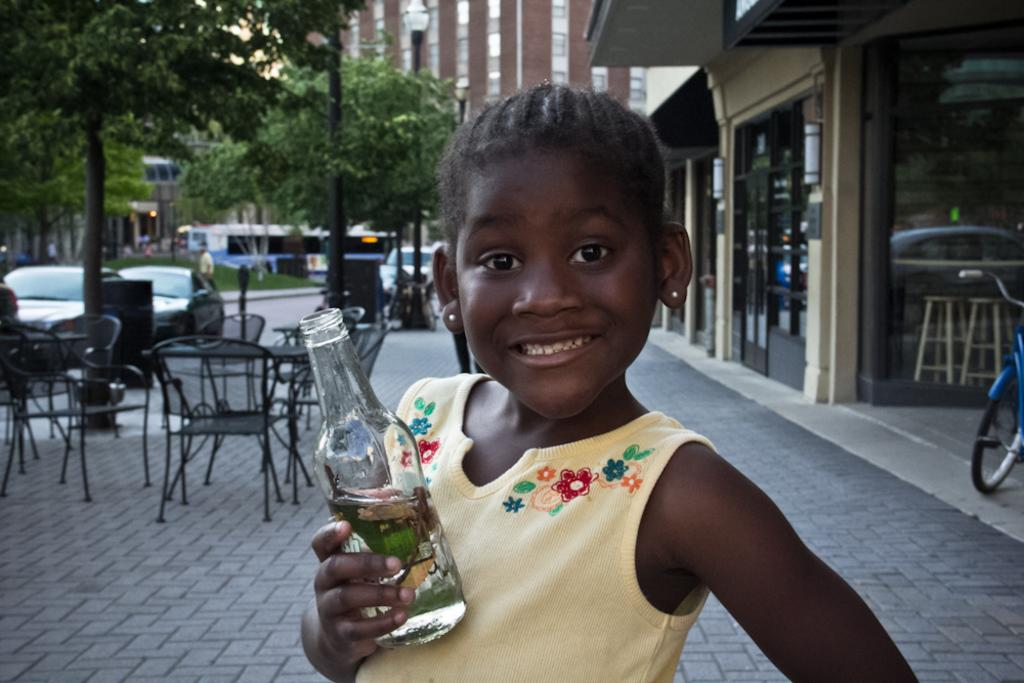Who is the main subject in the image? There is a girl in the image. What is the girl doing in the image? The girl is posing to the camera. What object is the girl holding in her hand? The girl is holding a bottle in her hand. What type of discussion is the girl having with the wind in the image? There is no wind or discussion present in the image; it only features a girl posing with a bottle. 